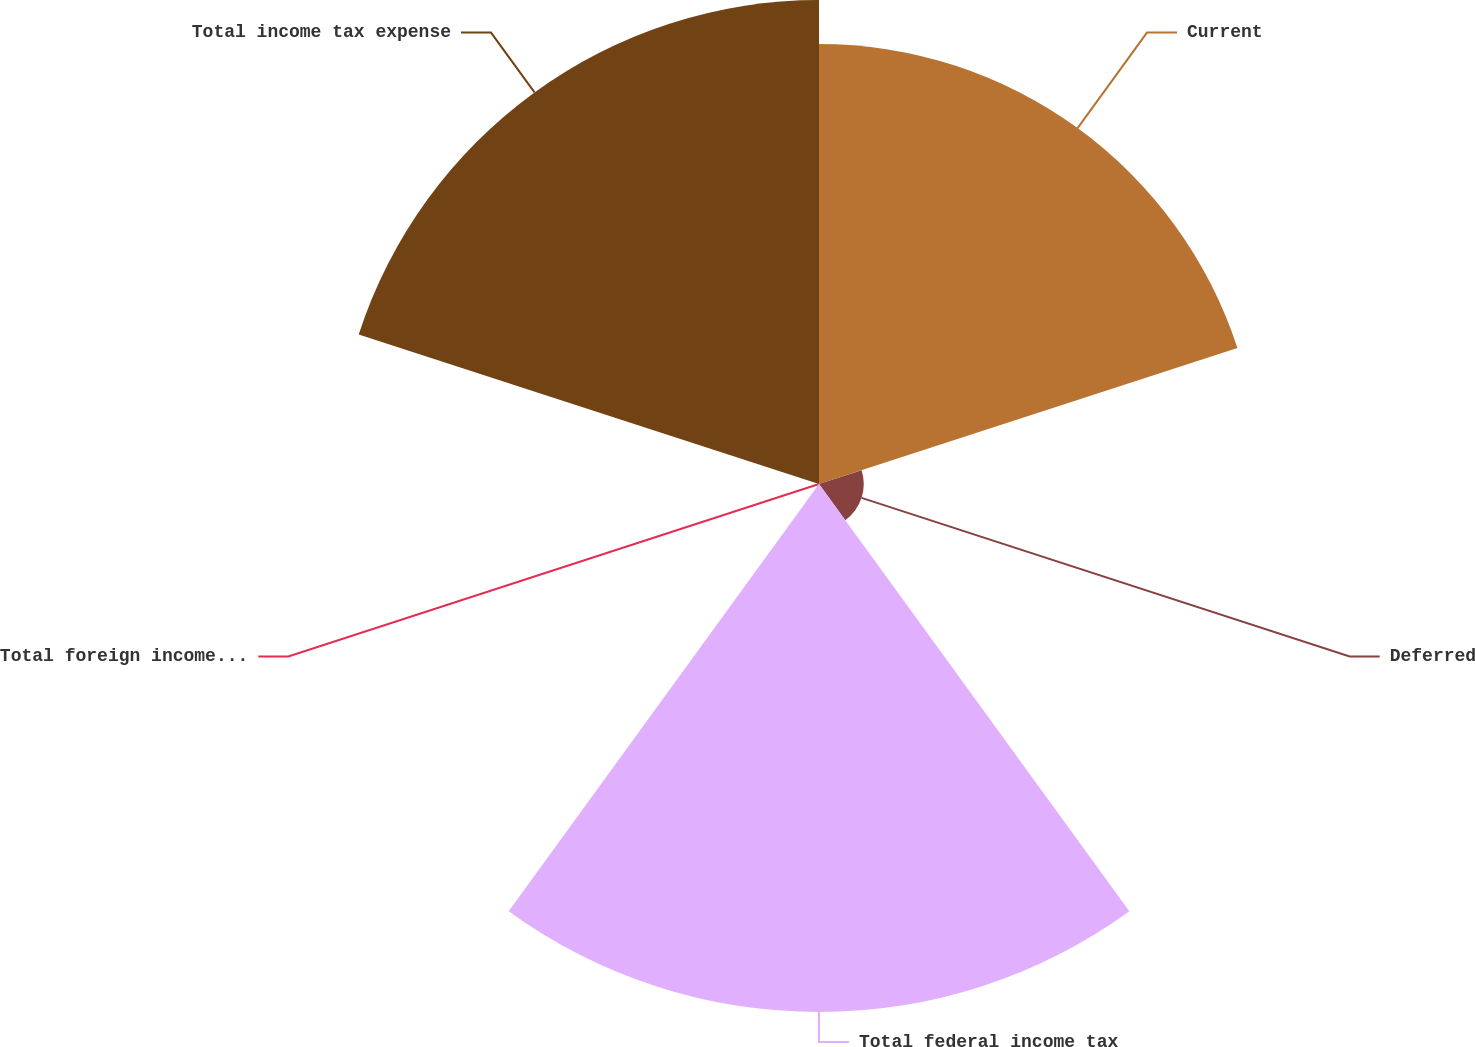Convert chart. <chart><loc_0><loc_0><loc_500><loc_500><pie_chart><fcel>Current<fcel>Deferred<fcel>Total federal income tax<fcel>Total foreign income tax<fcel>Total income tax expense<nl><fcel>29.38%<fcel>2.99%<fcel>35.26%<fcel>0.05%<fcel>32.32%<nl></chart> 